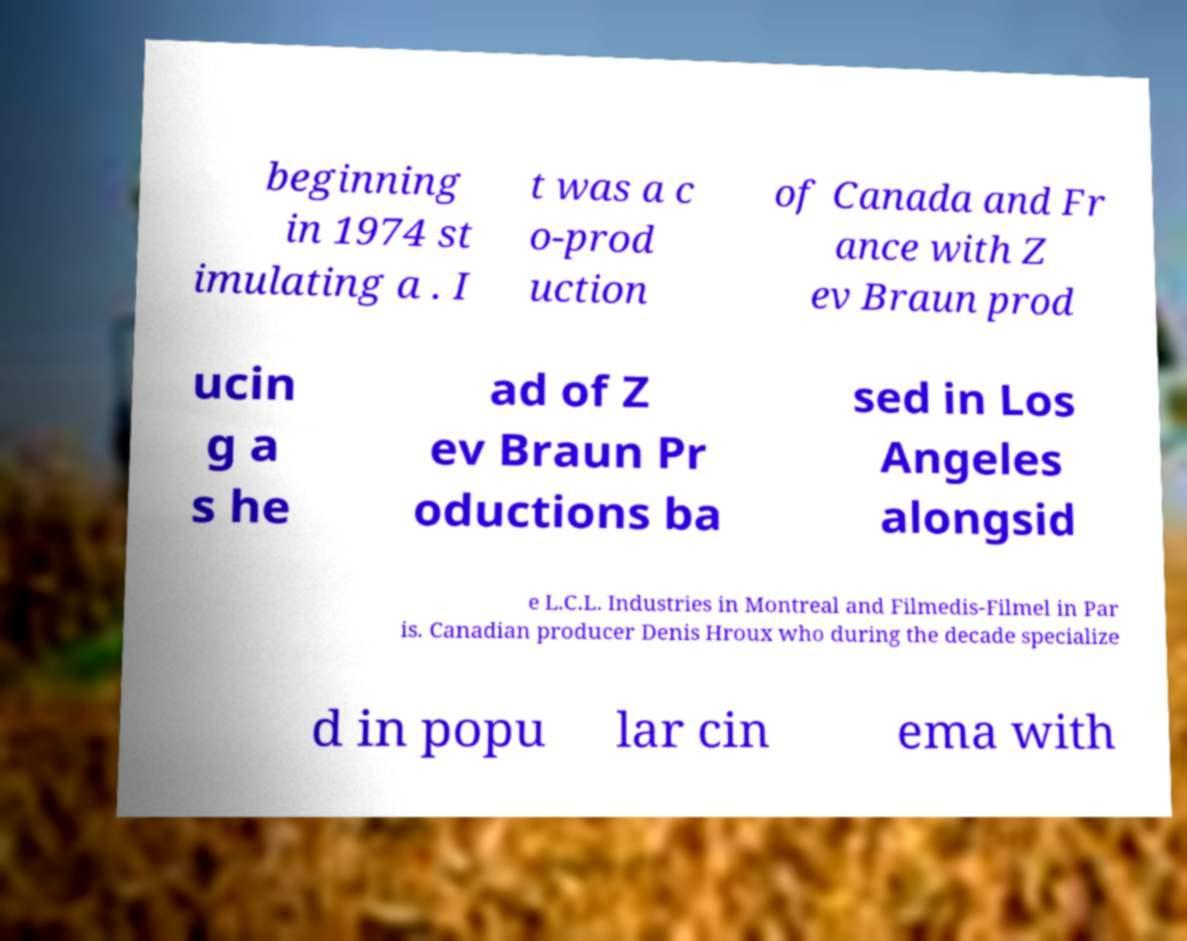There's text embedded in this image that I need extracted. Can you transcribe it verbatim? beginning in 1974 st imulating a . I t was a c o-prod uction of Canada and Fr ance with Z ev Braun prod ucin g a s he ad of Z ev Braun Pr oductions ba sed in Los Angeles alongsid e L.C.L. Industries in Montreal and Filmedis-Filmel in Par is. Canadian producer Denis Hroux who during the decade specialize d in popu lar cin ema with 